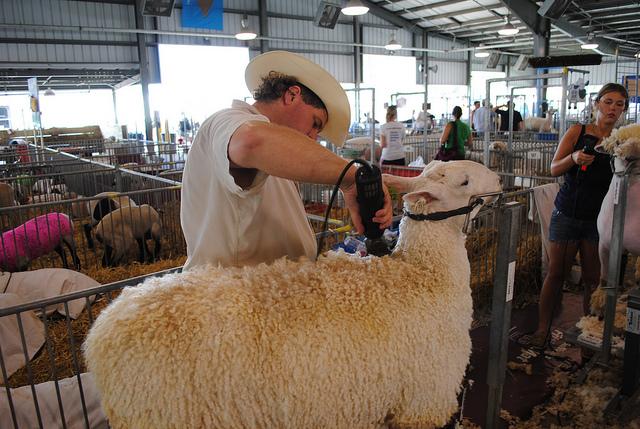Is the sheep alive?
Write a very short answer. Yes. What is the man doing to the sheep?
Short answer required. Shearing. Is the man shearing a sheep?
Short answer required. Yes. 